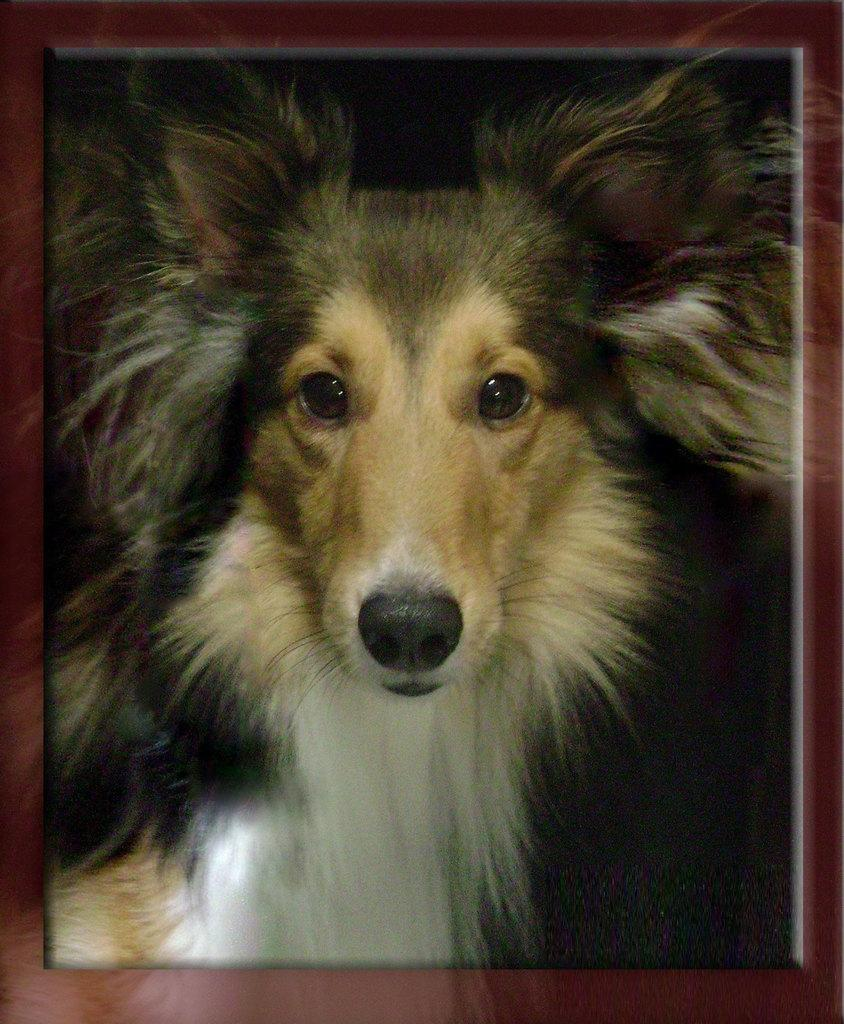What is the main subject of the image? The main subject of the image is a photo frame. What is depicted inside the photo frame? There is a photo of a dog inside the photo frame. What type of industry is depicted in the image? There is no industry depicted in the image; it features a photo frame with a photo of a dog. How can someone help the dog in the image? The dog in the image is a photograph, so it cannot be helped or interacted with in any way. 